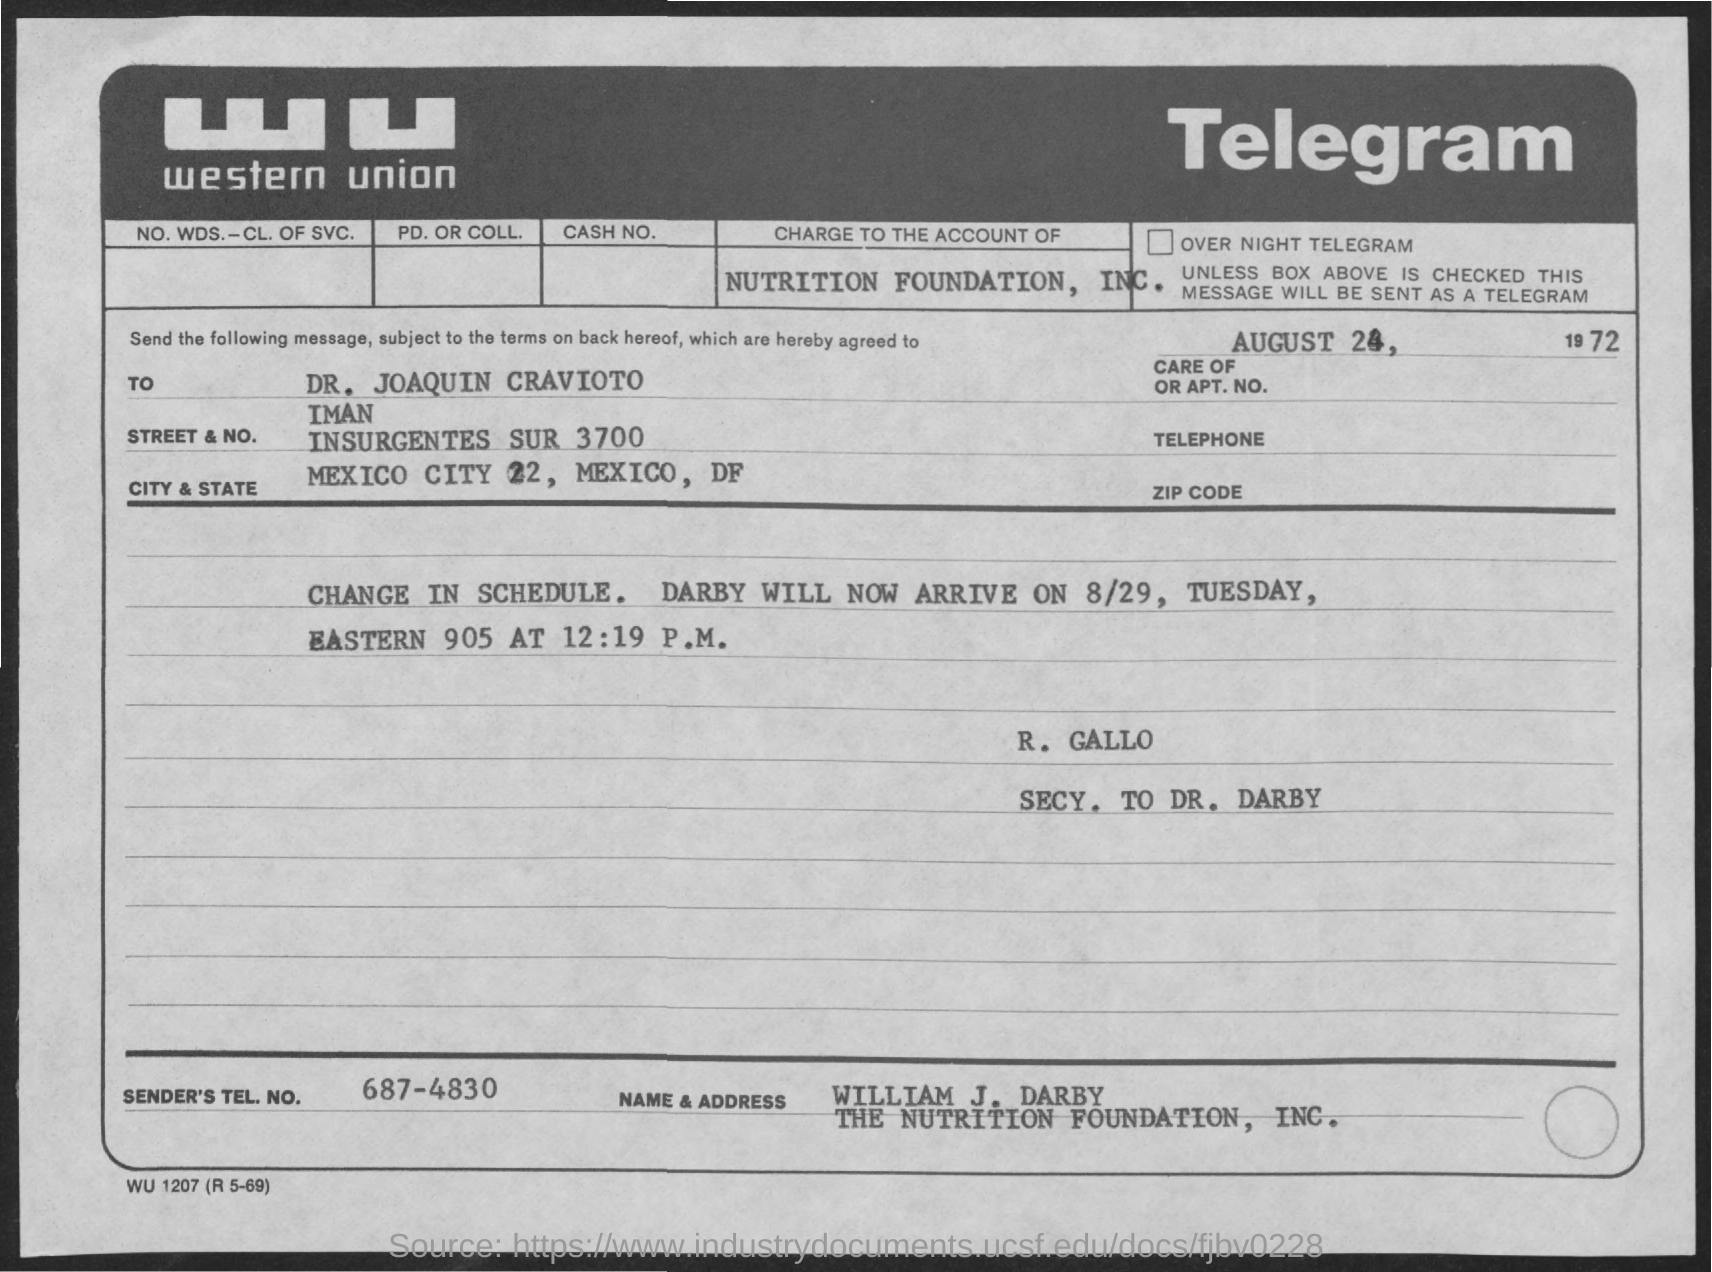What kind of communication is this?
Keep it short and to the point. Telegram. To whom, the message is send?
Your answer should be compact. DR. JOAQUIN CRAVIOTO. What is the sender's tel. no. given?
Your answer should be very brief. 687-4830. Who is the sender of this telegram?
Offer a terse response. William J. Darby. What is the date mentioned in this telegram?
Offer a very short reply. AUGUST 24, 1972. 